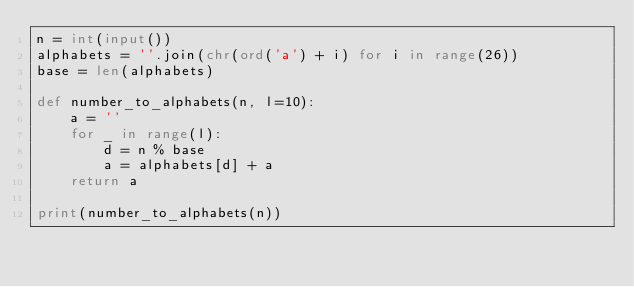Convert code to text. <code><loc_0><loc_0><loc_500><loc_500><_Python_>n = int(input())
alphabets = ''.join(chr(ord('a') + i) for i in range(26))
base = len(alphabets)

def number_to_alphabets(n, l=10):
    a = ''
    for _ in range(l):
        d = n % base
        a = alphabets[d] + a
    return a

print(number_to_alphabets(n))        </code> 